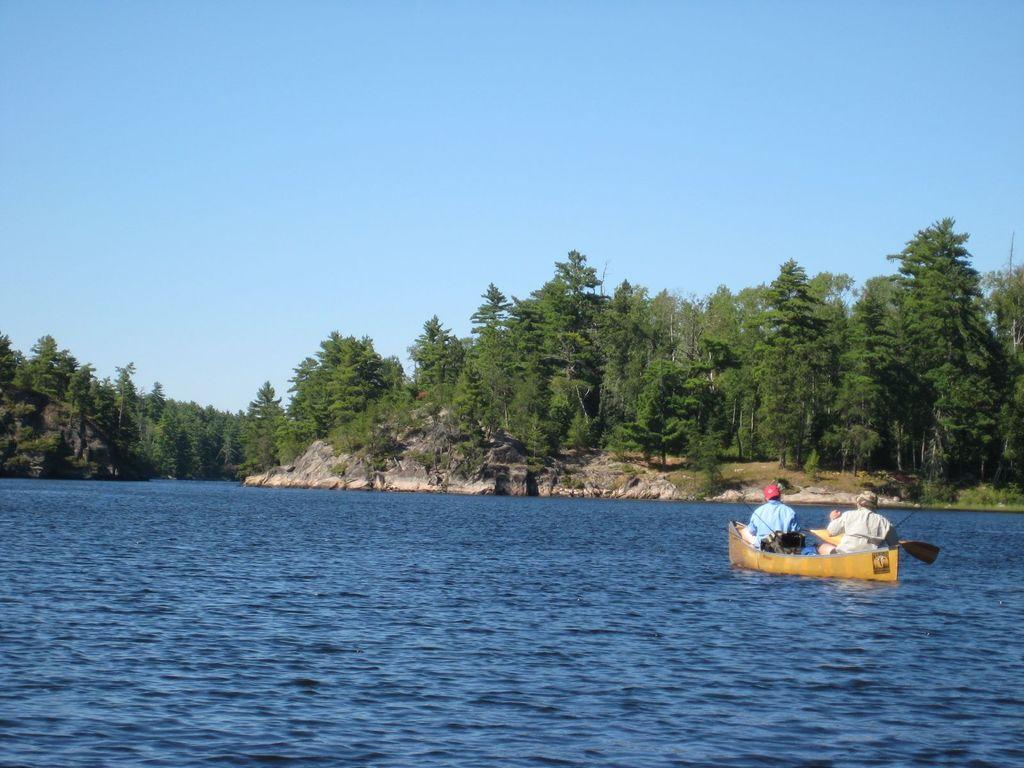What is in the water in the image? There is a boat in the water in the image. Who is in the boat? There are people sitting in the boat. What are the people wearing? The people are wearing clothes and caps. What is being used to propel the boat? There is a paddle visible in the image. What can be seen in the background of the image? There is a hill and trees in the background. What is the color of the sky in the image? The sky is pale blue. What type of nail is being used to hold the boat together in the image? There is no nail visible in the image, and the boat's construction is not mentioned. Can you see any magical elements in the image? There are no magical elements present in the image. 